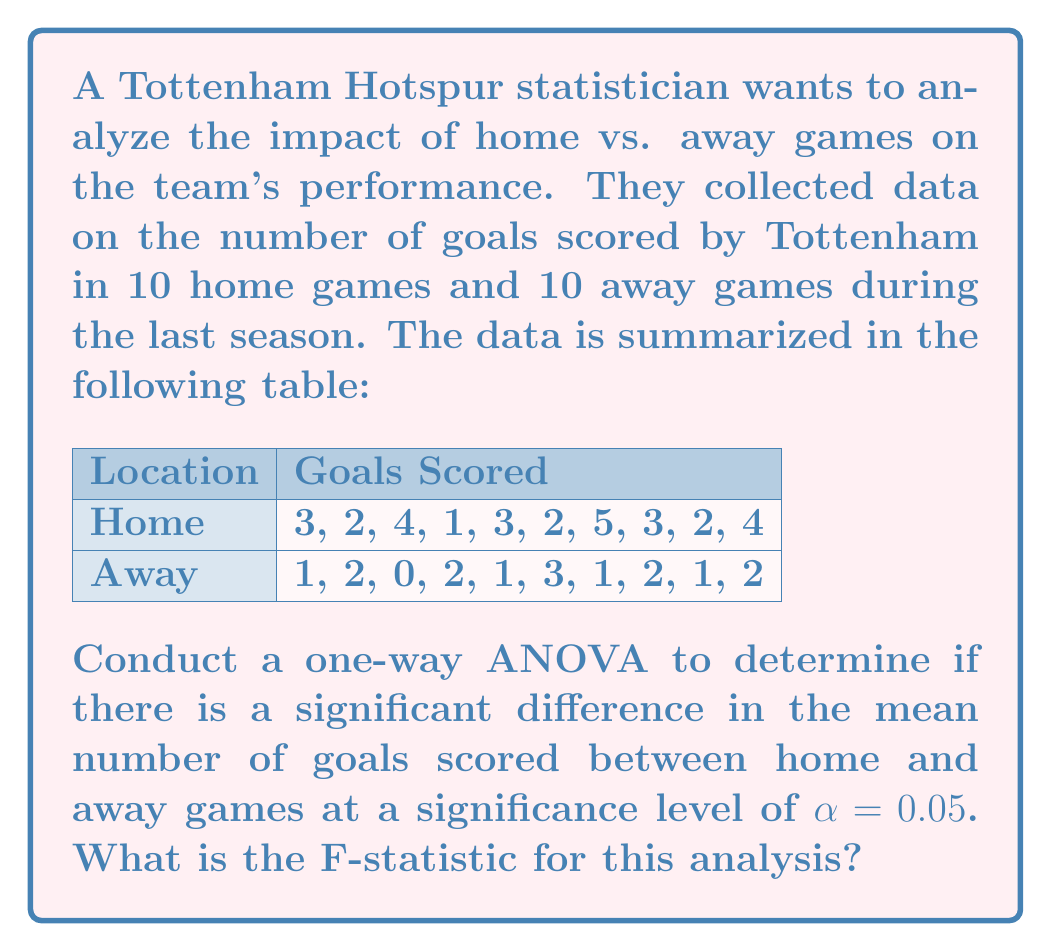Solve this math problem. To conduct a one-way ANOVA, we'll follow these steps:

1) Calculate the means for each group:
   Home mean: $\bar{X}_H = \frac{3 + 2 + 4 + 1 + 3 + 2 + 5 + 3 + 2 + 4}{10} = 2.9$
   Away mean: $\bar{X}_A = \frac{1 + 2 + 0 + 2 + 1 + 3 + 1 + 2 + 1 + 2}{10} = 1.5$
   Overall mean: $\bar{X} = \frac{2.9 + 1.5}{2} = 2.2$

2) Calculate the Sum of Squares Between groups (SSB):
   $SSB = n_H(\bar{X}_H - \bar{X})^2 + n_A(\bar{X}_A - \bar{X})^2$
   $SSB = 10(2.9 - 2.2)^2 + 10(1.5 - 2.2)^2 = 10(0.7)^2 + 10(-0.7)^2 = 9.8$

3) Calculate the Sum of Squares Within groups (SSW):
   $SSW = \sum_{i=1}^{10} (X_{Hi} - \bar{X}_H)^2 + \sum_{i=1}^{10} (X_{Ai} - \bar{X}_A)^2$
   For Home: $(3-2.9)^2 + (2-2.9)^2 + ... + (4-2.9)^2 = 11.9$
   For Away: $(1-1.5)^2 + (2-1.5)^2 + ... + (2-1.5)^2 = 7.5$
   $SSW = 11.9 + 7.5 = 19.4$

4) Calculate degrees of freedom:
   $df_{between} = k - 1 = 2 - 1 = 1$ (k is the number of groups)
   $df_{within} = N - k = 20 - 2 = 18$ (N is the total number of observations)

5) Calculate Mean Square Between (MSB) and Mean Square Within (MSW):
   $MSB = \frac{SSB}{df_{between}} = \frac{9.8}{1} = 9.8$
   $MSW = \frac{SSW}{df_{within}} = \frac{19.4}{18} = 1.0778$

6) Calculate the F-statistic:
   $F = \frac{MSB}{MSW} = \frac{9.8}{1.0778} = 9.0928$

The F-statistic for this analysis is approximately 9.0928.
Answer: $F = 9.0928$ 